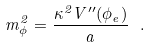Convert formula to latex. <formula><loc_0><loc_0><loc_500><loc_500>m _ { \phi } ^ { 2 } = \frac { \kappa ^ { 2 } V ^ { \prime \prime } ( \phi _ { e } ) } { a } \ .</formula> 